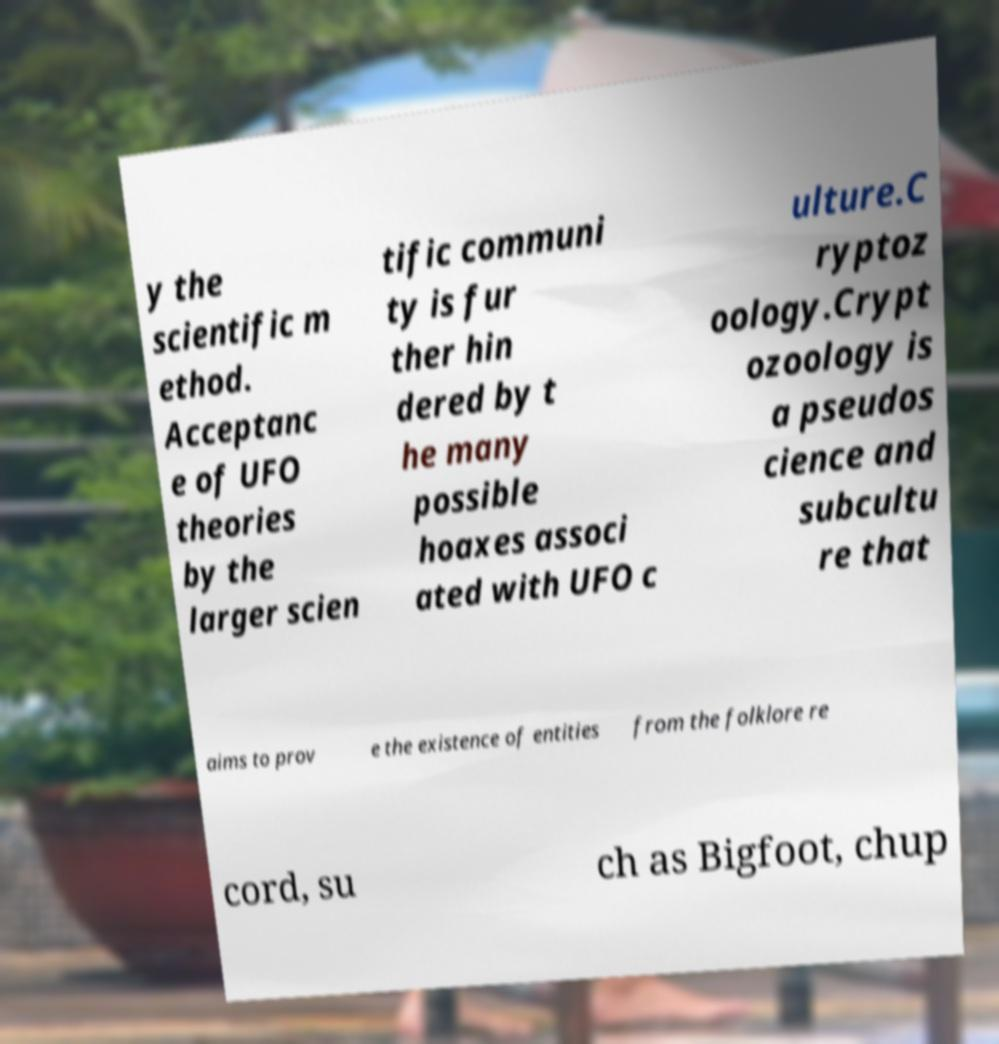I need the written content from this picture converted into text. Can you do that? y the scientific m ethod. Acceptanc e of UFO theories by the larger scien tific communi ty is fur ther hin dered by t he many possible hoaxes associ ated with UFO c ulture.C ryptoz oology.Crypt ozoology is a pseudos cience and subcultu re that aims to prov e the existence of entities from the folklore re cord, su ch as Bigfoot, chup 